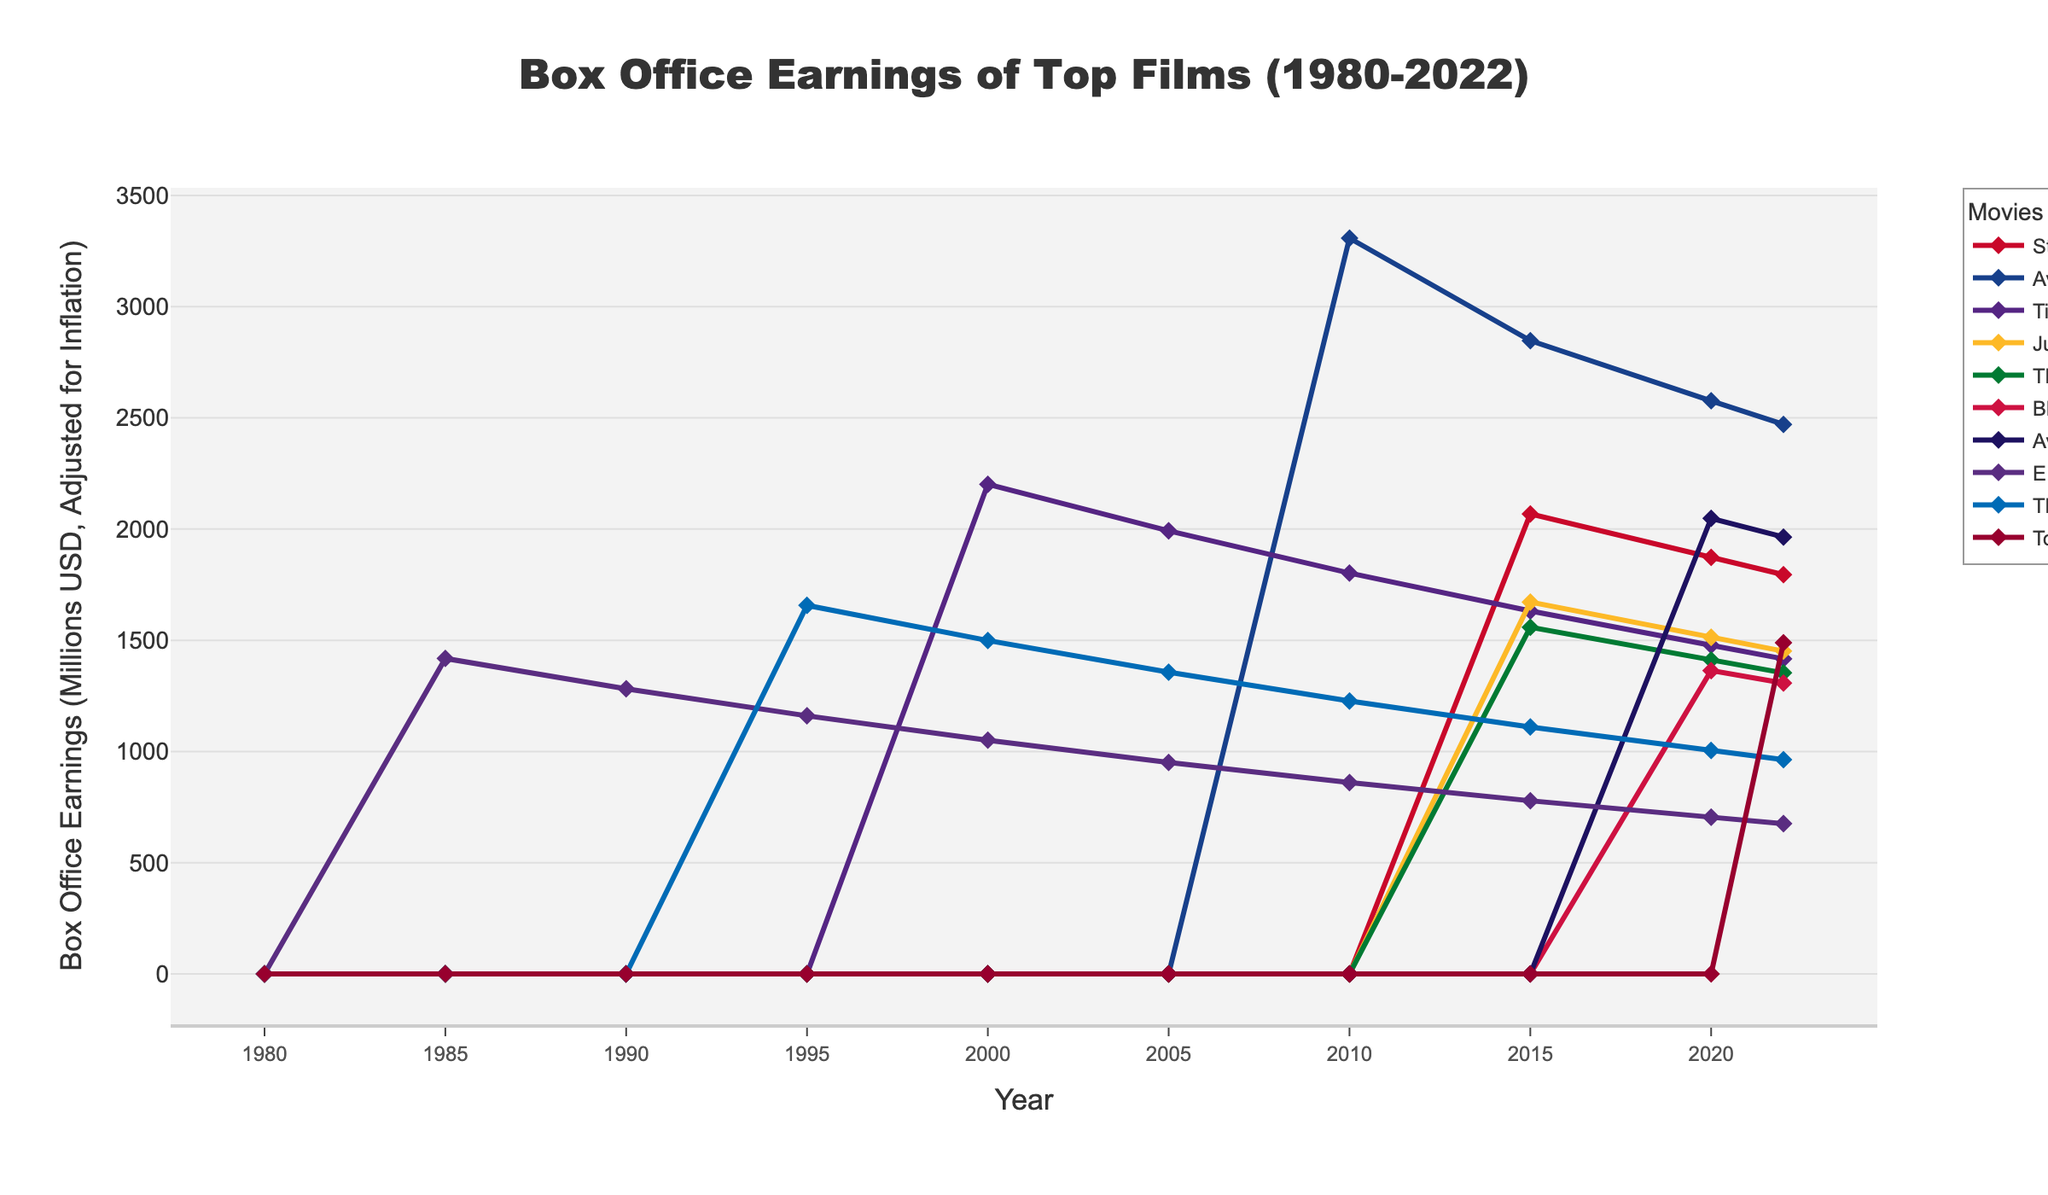Which film had the highest box office earnings in 2010? To determine the highest box office earnings in 2010, look at the data points for all films in the year 2010 and identify the film with the highest value. "Avatar" has the highest box office earnings for 2010.
Answer: Avatar What was the difference in box office earnings between "Titanic" and "Jurassic World" in 2020? Find the box office earnings for both "Titanic" and "Jurassic World" in the year 2020 and then subtract the earnings of "Jurassic World" from "Titanic". "Titanic" earned 1477.5 million and "Jurassic World" earned 1513.5 million in 2020, so the difference is 1513.5 - 1477.5 = 36 million.
Answer: 36 million Which movie had a higher box office earnings in 2022, "The Lion King" or "Top Gun: Maverick"? Compare the box office earnings for "The Lion King" and "Top Gun: Maverick" in the year 2022. "The Lion King" earned 963.5 million while "Top Gun: Maverick" earned 1488.7 million in 2022.
Answer: Top Gun: Maverick What is the average box office earnings of "E.T. the Extra-Terrestrial" over all recorded years? Sum the box office earnings of "E.T. the Extra-Terrestrial" from 1985, 1990, 1995, 2000, 2005, 2010, 2015, 2020, and 2022, then divide by the number of years. Sum = 1418.3 + 1282.1 + 1160.5 + 1050.8 + 950.7 + 860.3 + 778.5 + 704.7 + 675.8 = 8881.7, and there are 9 data points. Average = 8881.7 / 9 = 986.86 million.
Answer: 986.86 million Among all the listed years, in which year did "Star Wars: Episode VII - The Force Awakens" have the highest earnings? Look for the maximum value in the data points for "Star Wars: Episode VII - The Force Awakens" and identify the corresponding year. “Star Wars: Episode VII - The Force Awakens” earned the highest in 2015 with 2068.2 million.
Answer: 2015 Between "Avatar" and "Avengers: Infinity War," which movie had the higher earnings on average over all years they were recorded? Sum the earnings of each movie over the years they were recorded, then divide by the number of years. For "Avatar": sum = 3308.1 + 2847.2 + 2576.8 + 2470.8 = 11202.9, number of years = 4, average = 11202.9 / 4 = 2800.725 million. For "Avengers: Infinity War": sum = 2048.4 + 1964.1 = 4012.5, number of years = 2, average = 4012.5 / 2 = 2006.25 million. Therefore, "Avatar" has a higher average earnings.
Answer: Avatar What is the combined box office earnings of "E.T. the Extra-Terrestrial" and "The Lion King" in 2000? Add the earnings of "E.T. the Extra-Terrestrial" and "The Lion King" in the year 2000. "E.T. the Extra-Terrestrial" earned 1050.8 million and "The Lion King" earned 1499.3 million. Sum = 1050.8 + 1499.3 = 2550.1 million.
Answer: 2550.1 million In which year did "Black Panther" first appear in the box office records, and what were its earnings? Check for the first non-zero value for "Black Panther" and note the corresponding year and earnings. "Black Panther" first appeared in 2020 with earnings of 1363.7 million.
Answer: 2020 